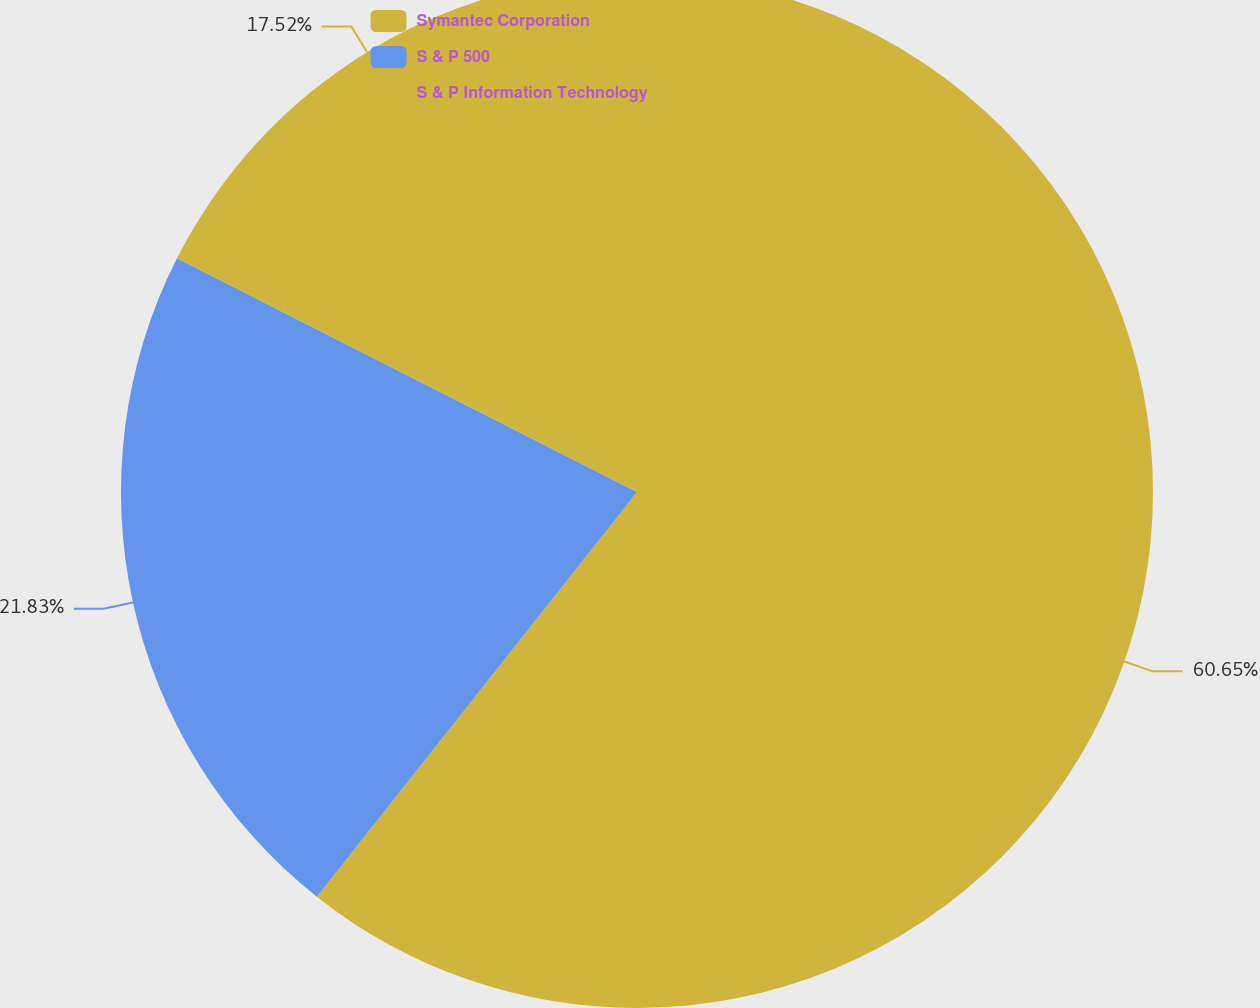Convert chart to OTSL. <chart><loc_0><loc_0><loc_500><loc_500><pie_chart><fcel>Symantec Corporation<fcel>S & P 500<fcel>S & P Information Technology<nl><fcel>60.66%<fcel>21.83%<fcel>17.52%<nl></chart> 